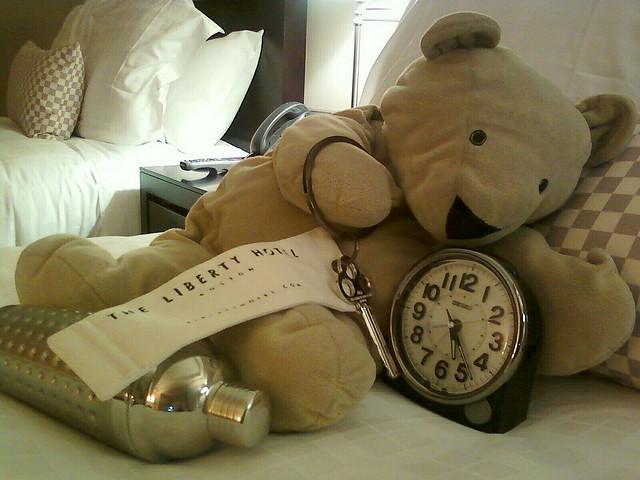How many beds are there?
Give a very brief answer. 3. 